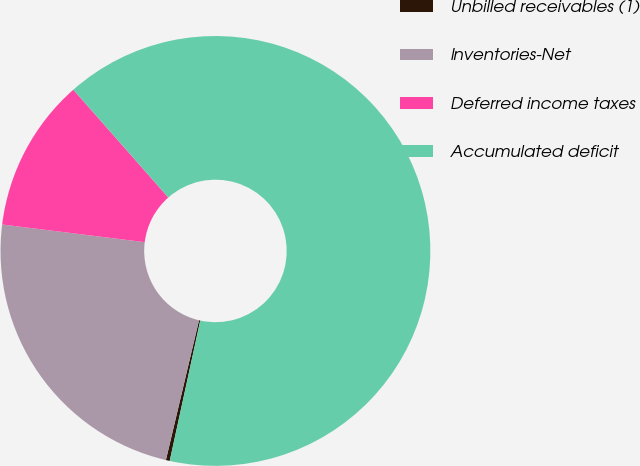<chart> <loc_0><loc_0><loc_500><loc_500><pie_chart><fcel>Unbilled receivables (1)<fcel>Inventories-Net<fcel>Deferred income taxes<fcel>Accumulated deficit<nl><fcel>0.29%<fcel>23.26%<fcel>11.54%<fcel>64.9%<nl></chart> 